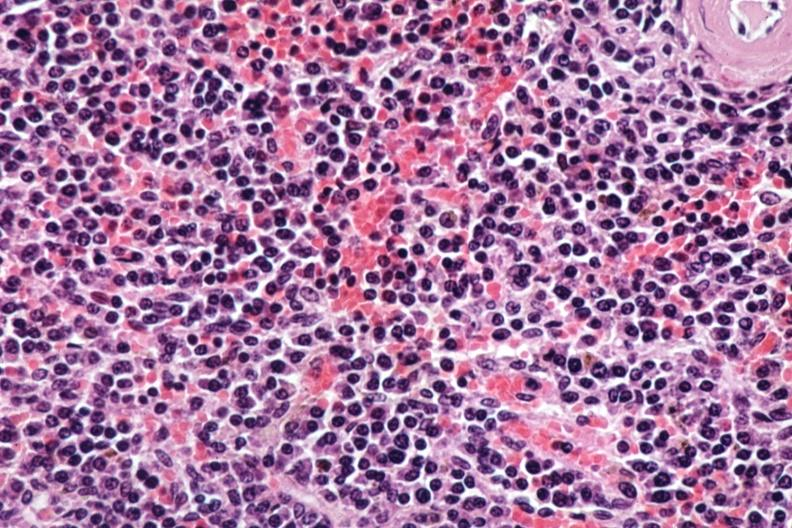s multiple myeloma present?
Answer the question using a single word or phrase. Yes 